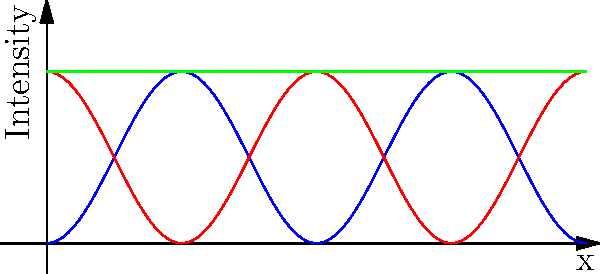As a data scientist applying machine learning techniques to social sciences research, you are tasked with analyzing the interference pattern from a double-slit experiment. The graph shows the intensity patterns of two individual waves (blue and red) and their combined interference pattern (green). What machine learning technique would be most appropriate for identifying and characterizing the peaks in the combined interference pattern, and why? To approach this problem, we need to consider the characteristics of the data and the goal of the analysis:

1. Data characteristics:
   - The data is a continuous wave pattern
   - There are clear peaks and troughs in the combined interference pattern
   - The pattern is periodic

2. Analysis goal:
   - Identify and characterize peaks in the combined interference pattern

Given these factors, an appropriate machine learning technique would be a Convolutional Neural Network (CNN) for the following reasons:

1. CNNs are excellent at detecting patterns in spatial data, which is ideal for analyzing wave interference patterns.

2. The convolutional layers in a CNN can act as feature detectors, identifying characteristics of the peaks such as height, width, and periodicity.

3. CNNs can be trained to recognize patterns at different scales, which is useful for identifying both major and minor peaks in the interference pattern.

4. The pooling layers in a CNN can help in reducing the dimensionality of the data while preserving important features, making the analysis more computationally efficient.

5. CNNs can be adapted to handle 1D data (like our wave pattern) by using 1D convolutional layers.

6. Once trained, a CNN can quickly analyze new interference patterns, making it suitable for real-time applications or large-scale data analysis.

7. The learned features from the CNN can be visualized, providing insights into what characteristics the model is using to identify peaks, which can be valuable for interpreting the results in the context of social sciences research.

While other techniques like peak detection algorithms or Fourier analysis could also be used, a CNN offers the advantage of being able to learn complex patterns and adapt to variations in the data, which could be particularly useful if the interference patterns vary across different experimental conditions or social contexts.
Answer: Convolutional Neural Network (CNN) 